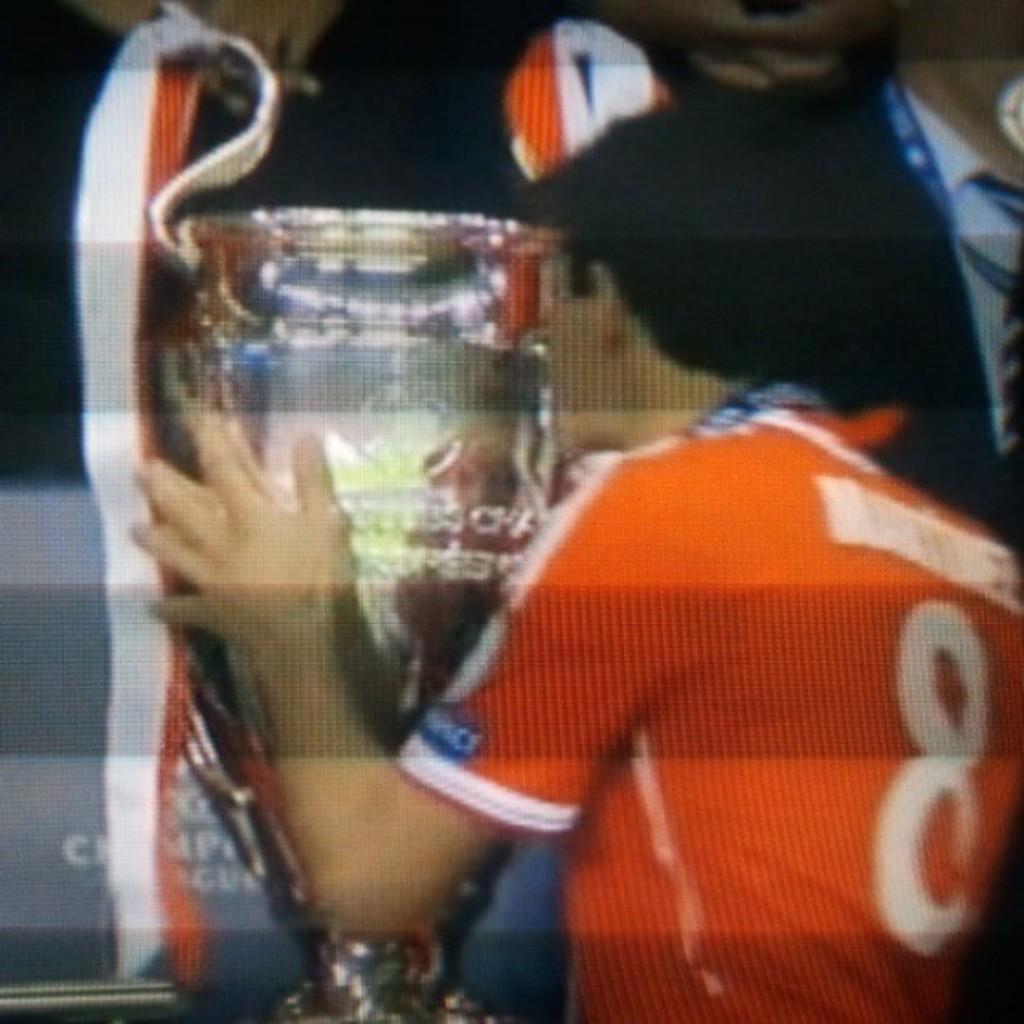What jersey number is the man in the photo wearing?
Provide a short and direct response. 8. What is the single letter on the left side of the white stripe?
Offer a very short reply. C. 